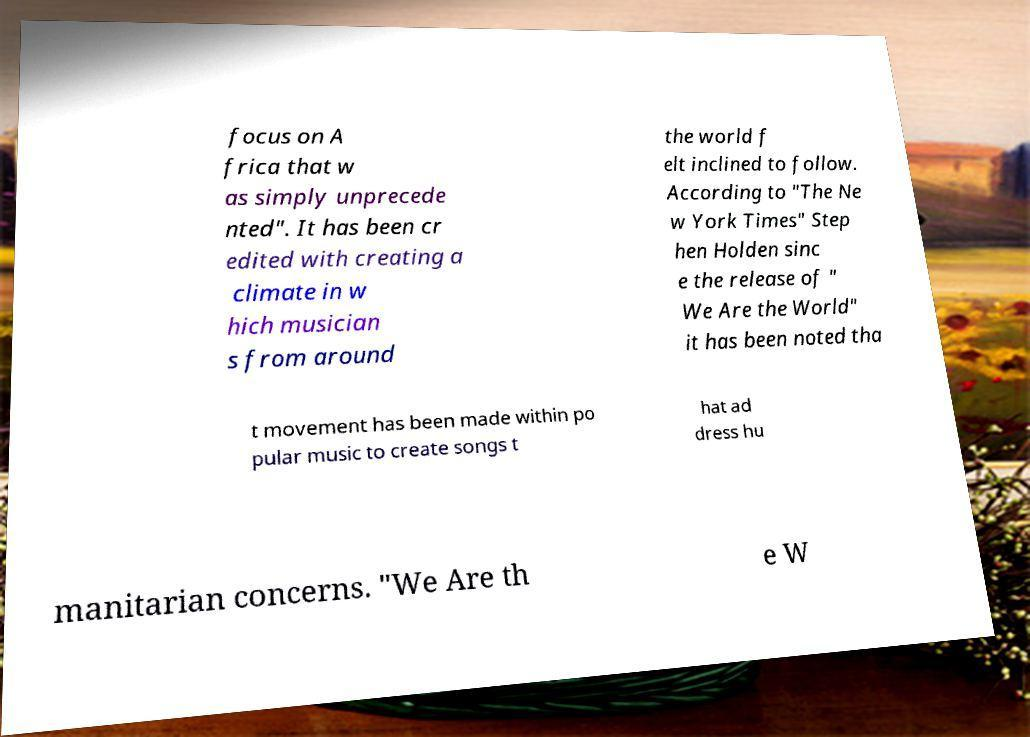For documentation purposes, I need the text within this image transcribed. Could you provide that? focus on A frica that w as simply unprecede nted". It has been cr edited with creating a climate in w hich musician s from around the world f elt inclined to follow. According to "The Ne w York Times" Step hen Holden sinc e the release of " We Are the World" it has been noted tha t movement has been made within po pular music to create songs t hat ad dress hu manitarian concerns. "We Are th e W 